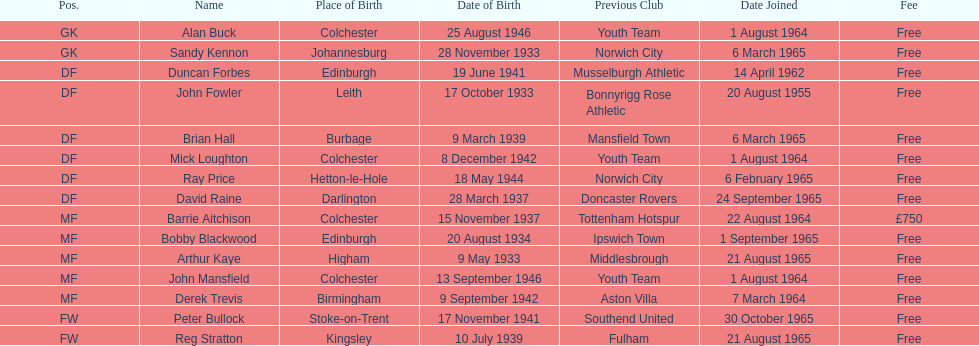How many players are listed as df? 6. 